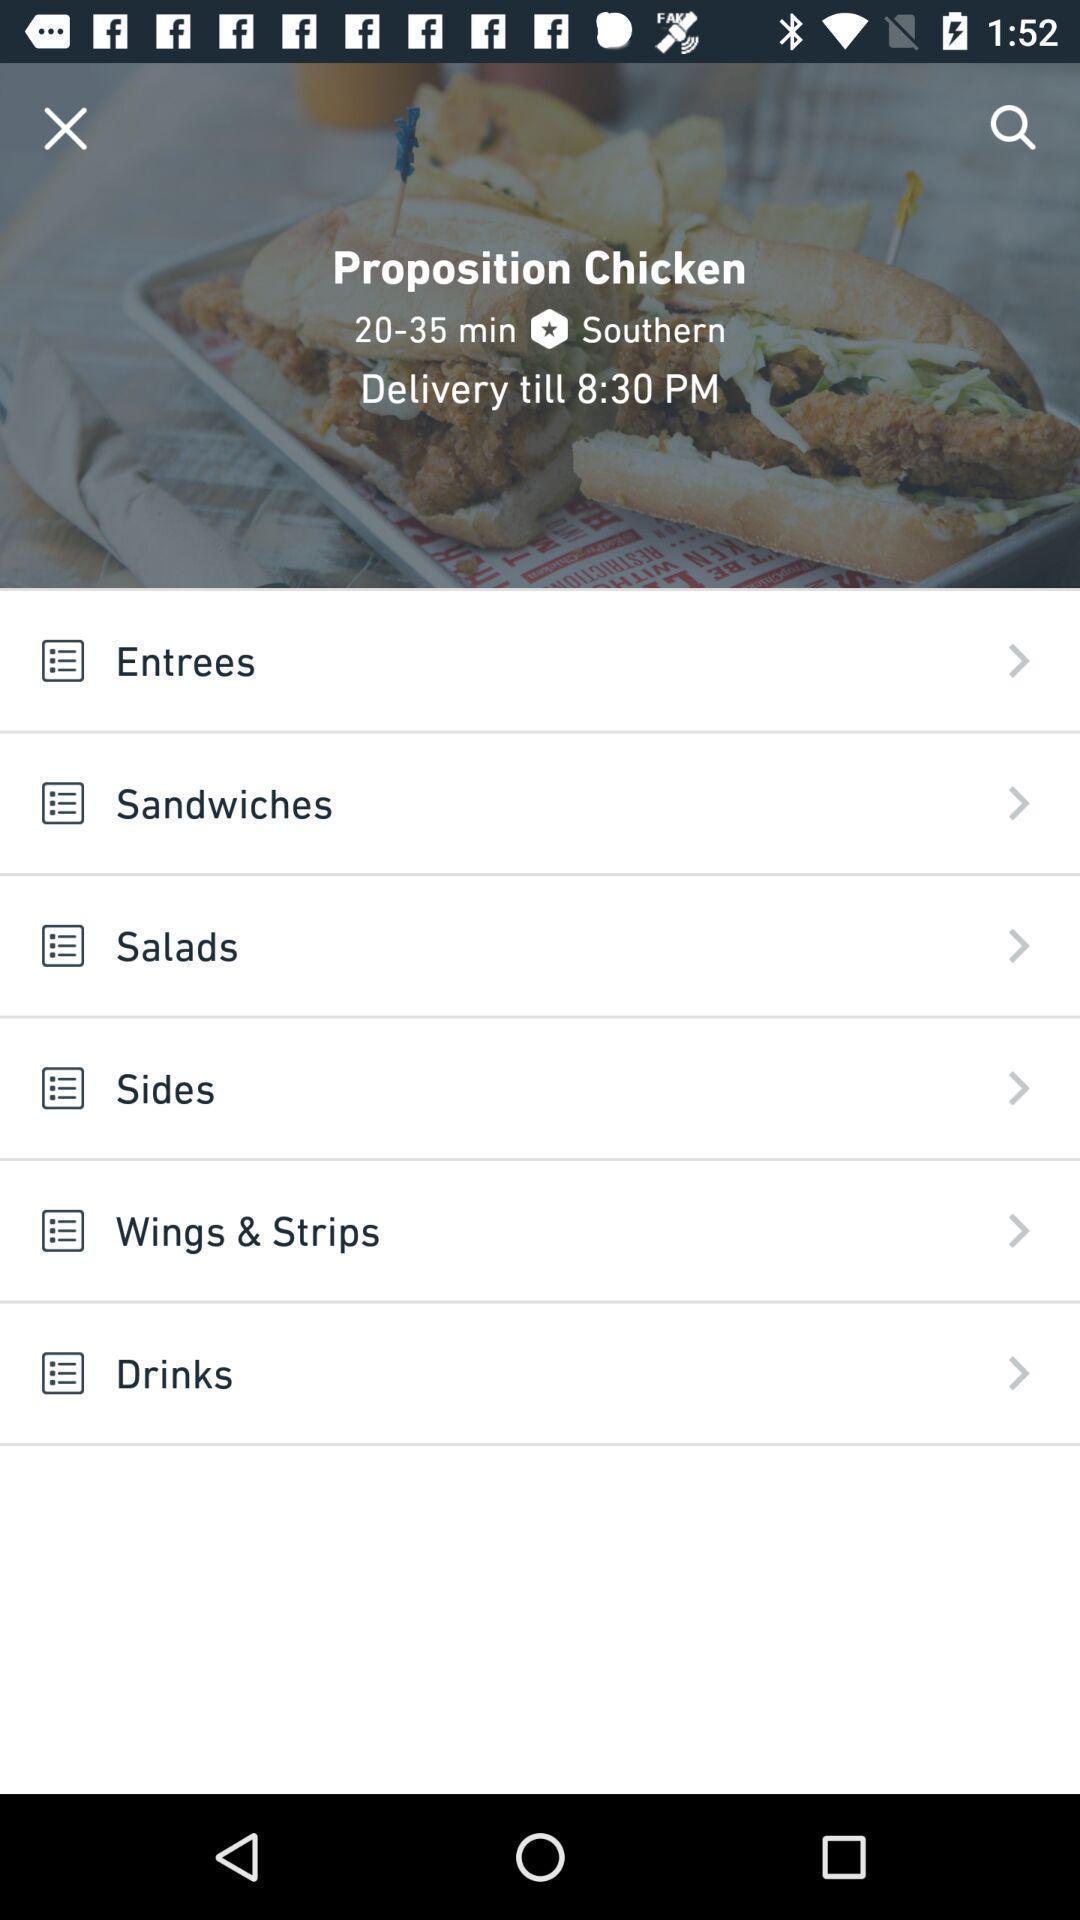What is the overall content of this screenshot? Screen displaying list of food items. 